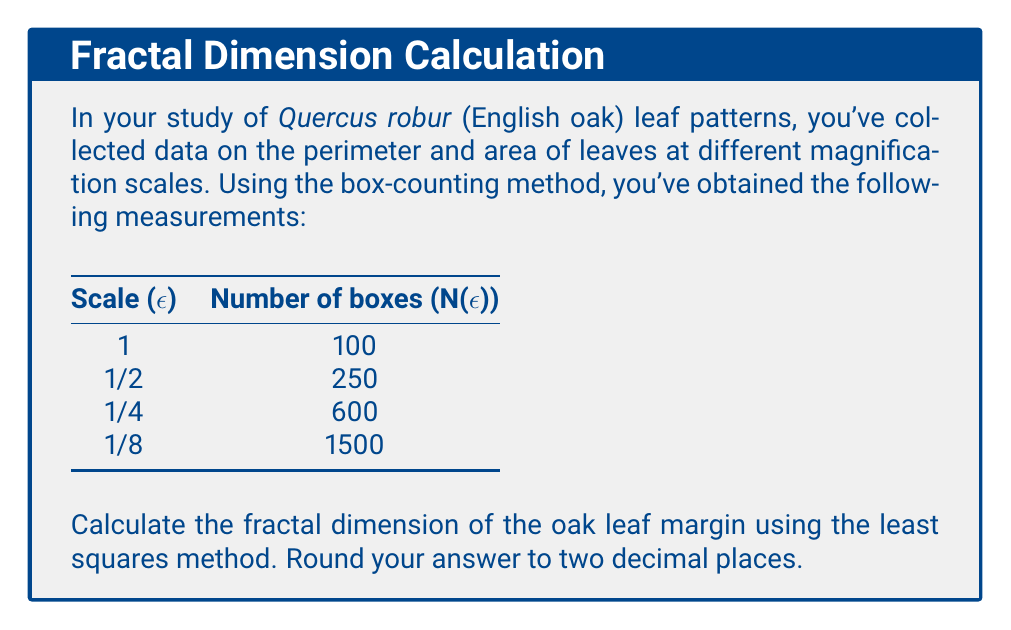Teach me how to tackle this problem. To calculate the fractal dimension using the box-counting method and least squares:

1. The fractal dimension D is given by the slope of the log-log plot of N(ε) vs 1/ε.

2. We need to set up the following data:
   x = log(1/ε)
   y = log(N(ε))

3. Calculate x and y values:
   
   ε    | 1/ε  | x = log(1/ε) | N(ε) | y = log(N(ε))
   1    | 1    | 0            | 100  | 4.60517
   1/2  | 2    | 0.69315      | 250  | 5.52146
   1/4  | 4    | 1.38629      | 600  | 6.39693
   1/8  | 8    | 2.07944      | 1500 | 7.31322

4. Use the least squares formula for the slope:
   
   $$D = \frac{n\sum xy - \sum x \sum y}{n\sum x^2 - (\sum x)^2}$$

   Where n is the number of data points (4 in this case).

5. Calculate the sums:
   $$\sum x = 4.15888$$
   $$\sum y = 23.83678$$
   $$\sum xy = 26.78459$$
   $$\sum x^2 = 7.14583$$

6. Substitute into the formula:
   
   $$D = \frac{4(26.78459) - (4.15888)(23.83678)}{4(7.14583) - (4.15888)^2}$$

7. Solve:
   $$D = \frac{107.13836 - 99.13305}{28.58332 - 17.29631} = \frac{8.00531}{11.28701} = 0.70925$$

8. Round to two decimal places: 0.71

The fractal dimension of 0.71 indicates that the oak leaf margin is more complex than a smooth line (dimension 1) but less complex than a plane-filling curve (dimension 2).
Answer: 0.71 